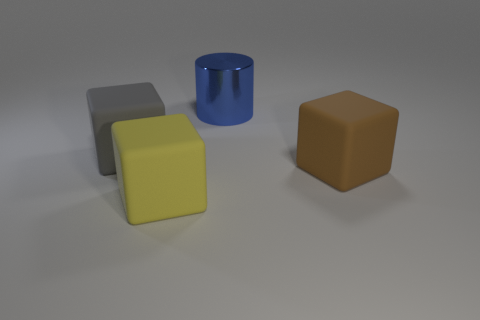What is the shape of the large thing behind the block on the left side of the yellow thing? The large object behind the block on the left side of the yellow cube is a cylinder with a reflective blue surface. 